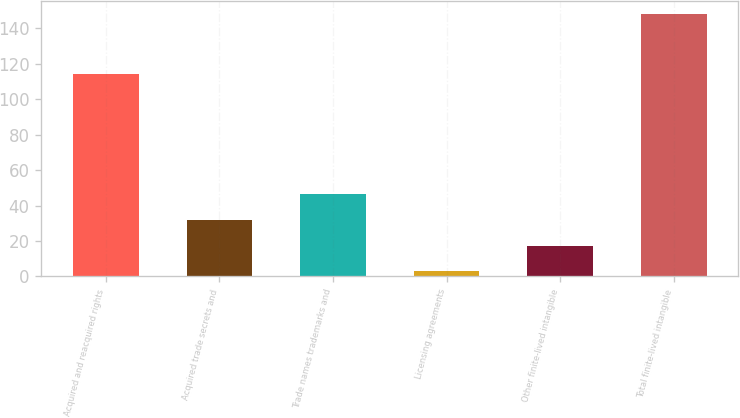Convert chart. <chart><loc_0><loc_0><loc_500><loc_500><bar_chart><fcel>Acquired and reacquired rights<fcel>Acquired trade secrets and<fcel>Trade names trademarks and<fcel>Licensing agreements<fcel>Other finite-lived intangible<fcel>Total finite-lived intangible<nl><fcel>114.5<fcel>31.86<fcel>46.39<fcel>2.8<fcel>17.33<fcel>148.1<nl></chart> 